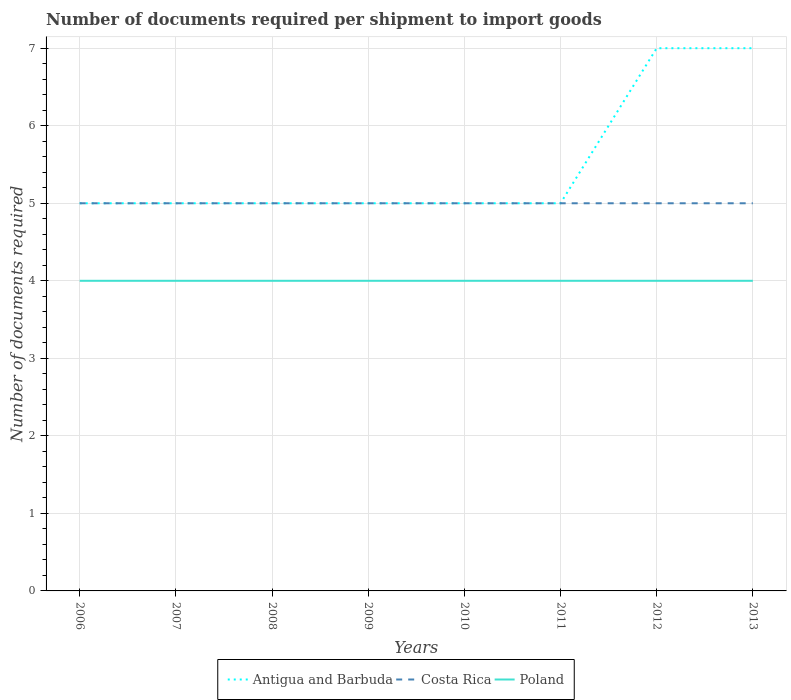How many different coloured lines are there?
Make the answer very short. 3. Across all years, what is the maximum number of documents required per shipment to import goods in Poland?
Offer a very short reply. 4. In which year was the number of documents required per shipment to import goods in Poland maximum?
Offer a terse response. 2006. What is the total number of documents required per shipment to import goods in Antigua and Barbuda in the graph?
Make the answer very short. -2. What is the difference between the highest and the second highest number of documents required per shipment to import goods in Poland?
Make the answer very short. 0. Is the number of documents required per shipment to import goods in Poland strictly greater than the number of documents required per shipment to import goods in Antigua and Barbuda over the years?
Offer a very short reply. Yes. How many lines are there?
Provide a succinct answer. 3. Where does the legend appear in the graph?
Your answer should be very brief. Bottom center. What is the title of the graph?
Make the answer very short. Number of documents required per shipment to import goods. Does "Singapore" appear as one of the legend labels in the graph?
Ensure brevity in your answer.  No. What is the label or title of the Y-axis?
Offer a very short reply. Number of documents required. What is the Number of documents required in Costa Rica in 2006?
Your response must be concise. 5. What is the Number of documents required of Poland in 2006?
Your answer should be compact. 4. What is the Number of documents required in Poland in 2007?
Your answer should be very brief. 4. What is the Number of documents required of Antigua and Barbuda in 2008?
Your answer should be compact. 5. What is the Number of documents required of Costa Rica in 2008?
Provide a succinct answer. 5. What is the Number of documents required in Poland in 2008?
Provide a short and direct response. 4. What is the Number of documents required of Costa Rica in 2009?
Make the answer very short. 5. What is the Number of documents required in Poland in 2009?
Offer a very short reply. 4. What is the Number of documents required of Costa Rica in 2011?
Offer a terse response. 5. What is the Number of documents required in Poland in 2011?
Give a very brief answer. 4. What is the Number of documents required of Antigua and Barbuda in 2012?
Your response must be concise. 7. What is the Number of documents required of Poland in 2012?
Make the answer very short. 4. What is the Number of documents required in Antigua and Barbuda in 2013?
Ensure brevity in your answer.  7. What is the Number of documents required of Costa Rica in 2013?
Your response must be concise. 5. What is the Number of documents required in Poland in 2013?
Your answer should be very brief. 4. Across all years, what is the maximum Number of documents required of Antigua and Barbuda?
Give a very brief answer. 7. Across all years, what is the minimum Number of documents required in Costa Rica?
Ensure brevity in your answer.  5. What is the total Number of documents required of Antigua and Barbuda in the graph?
Provide a succinct answer. 44. What is the total Number of documents required in Poland in the graph?
Your response must be concise. 32. What is the difference between the Number of documents required of Antigua and Barbuda in 2006 and that in 2007?
Your response must be concise. 0. What is the difference between the Number of documents required of Antigua and Barbuda in 2006 and that in 2008?
Your response must be concise. 0. What is the difference between the Number of documents required of Costa Rica in 2006 and that in 2008?
Offer a terse response. 0. What is the difference between the Number of documents required of Poland in 2006 and that in 2008?
Give a very brief answer. 0. What is the difference between the Number of documents required of Poland in 2006 and that in 2009?
Offer a terse response. 0. What is the difference between the Number of documents required of Costa Rica in 2006 and that in 2011?
Keep it short and to the point. 0. What is the difference between the Number of documents required in Poland in 2006 and that in 2011?
Provide a succinct answer. 0. What is the difference between the Number of documents required of Costa Rica in 2006 and that in 2012?
Your response must be concise. 0. What is the difference between the Number of documents required in Antigua and Barbuda in 2007 and that in 2008?
Make the answer very short. 0. What is the difference between the Number of documents required of Costa Rica in 2007 and that in 2008?
Your answer should be very brief. 0. What is the difference between the Number of documents required in Antigua and Barbuda in 2007 and that in 2009?
Your answer should be compact. 0. What is the difference between the Number of documents required in Costa Rica in 2007 and that in 2009?
Your response must be concise. 0. What is the difference between the Number of documents required in Antigua and Barbuda in 2007 and that in 2010?
Keep it short and to the point. 0. What is the difference between the Number of documents required in Costa Rica in 2007 and that in 2010?
Make the answer very short. 0. What is the difference between the Number of documents required in Costa Rica in 2007 and that in 2011?
Your response must be concise. 0. What is the difference between the Number of documents required in Costa Rica in 2007 and that in 2013?
Make the answer very short. 0. What is the difference between the Number of documents required in Antigua and Barbuda in 2008 and that in 2010?
Your answer should be very brief. 0. What is the difference between the Number of documents required of Costa Rica in 2008 and that in 2011?
Make the answer very short. 0. What is the difference between the Number of documents required in Poland in 2008 and that in 2011?
Your response must be concise. 0. What is the difference between the Number of documents required of Antigua and Barbuda in 2008 and that in 2012?
Ensure brevity in your answer.  -2. What is the difference between the Number of documents required in Poland in 2008 and that in 2012?
Provide a succinct answer. 0. What is the difference between the Number of documents required in Poland in 2008 and that in 2013?
Offer a very short reply. 0. What is the difference between the Number of documents required in Costa Rica in 2009 and that in 2010?
Ensure brevity in your answer.  0. What is the difference between the Number of documents required of Poland in 2009 and that in 2010?
Give a very brief answer. 0. What is the difference between the Number of documents required in Costa Rica in 2009 and that in 2011?
Your answer should be very brief. 0. What is the difference between the Number of documents required in Antigua and Barbuda in 2009 and that in 2012?
Offer a very short reply. -2. What is the difference between the Number of documents required of Poland in 2009 and that in 2012?
Give a very brief answer. 0. What is the difference between the Number of documents required of Poland in 2009 and that in 2013?
Make the answer very short. 0. What is the difference between the Number of documents required of Poland in 2010 and that in 2011?
Provide a succinct answer. 0. What is the difference between the Number of documents required of Costa Rica in 2010 and that in 2012?
Provide a succinct answer. 0. What is the difference between the Number of documents required in Costa Rica in 2010 and that in 2013?
Give a very brief answer. 0. What is the difference between the Number of documents required in Poland in 2010 and that in 2013?
Give a very brief answer. 0. What is the difference between the Number of documents required of Costa Rica in 2011 and that in 2012?
Provide a short and direct response. 0. What is the difference between the Number of documents required in Poland in 2011 and that in 2012?
Provide a short and direct response. 0. What is the difference between the Number of documents required in Costa Rica in 2011 and that in 2013?
Your answer should be compact. 0. What is the difference between the Number of documents required of Antigua and Barbuda in 2012 and that in 2013?
Make the answer very short. 0. What is the difference between the Number of documents required of Antigua and Barbuda in 2006 and the Number of documents required of Costa Rica in 2007?
Make the answer very short. 0. What is the difference between the Number of documents required in Antigua and Barbuda in 2006 and the Number of documents required in Costa Rica in 2009?
Make the answer very short. 0. What is the difference between the Number of documents required in Costa Rica in 2006 and the Number of documents required in Poland in 2009?
Offer a terse response. 1. What is the difference between the Number of documents required in Antigua and Barbuda in 2006 and the Number of documents required in Poland in 2010?
Offer a very short reply. 1. What is the difference between the Number of documents required in Costa Rica in 2006 and the Number of documents required in Poland in 2010?
Keep it short and to the point. 1. What is the difference between the Number of documents required in Antigua and Barbuda in 2006 and the Number of documents required in Costa Rica in 2011?
Your answer should be compact. 0. What is the difference between the Number of documents required of Antigua and Barbuda in 2006 and the Number of documents required of Poland in 2012?
Your answer should be compact. 1. What is the difference between the Number of documents required in Costa Rica in 2006 and the Number of documents required in Poland in 2013?
Make the answer very short. 1. What is the difference between the Number of documents required in Costa Rica in 2007 and the Number of documents required in Poland in 2008?
Make the answer very short. 1. What is the difference between the Number of documents required of Antigua and Barbuda in 2007 and the Number of documents required of Costa Rica in 2009?
Ensure brevity in your answer.  0. What is the difference between the Number of documents required of Antigua and Barbuda in 2007 and the Number of documents required of Poland in 2009?
Provide a succinct answer. 1. What is the difference between the Number of documents required of Costa Rica in 2007 and the Number of documents required of Poland in 2009?
Provide a succinct answer. 1. What is the difference between the Number of documents required in Antigua and Barbuda in 2007 and the Number of documents required in Costa Rica in 2010?
Provide a short and direct response. 0. What is the difference between the Number of documents required in Antigua and Barbuda in 2007 and the Number of documents required in Poland in 2010?
Your response must be concise. 1. What is the difference between the Number of documents required of Costa Rica in 2007 and the Number of documents required of Poland in 2010?
Provide a succinct answer. 1. What is the difference between the Number of documents required of Antigua and Barbuda in 2007 and the Number of documents required of Poland in 2011?
Give a very brief answer. 1. What is the difference between the Number of documents required of Costa Rica in 2007 and the Number of documents required of Poland in 2011?
Provide a short and direct response. 1. What is the difference between the Number of documents required in Antigua and Barbuda in 2007 and the Number of documents required in Poland in 2012?
Provide a short and direct response. 1. What is the difference between the Number of documents required of Costa Rica in 2007 and the Number of documents required of Poland in 2013?
Keep it short and to the point. 1. What is the difference between the Number of documents required in Antigua and Barbuda in 2008 and the Number of documents required in Costa Rica in 2009?
Ensure brevity in your answer.  0. What is the difference between the Number of documents required in Costa Rica in 2008 and the Number of documents required in Poland in 2010?
Ensure brevity in your answer.  1. What is the difference between the Number of documents required in Antigua and Barbuda in 2008 and the Number of documents required in Costa Rica in 2011?
Provide a succinct answer. 0. What is the difference between the Number of documents required of Antigua and Barbuda in 2008 and the Number of documents required of Poland in 2011?
Make the answer very short. 1. What is the difference between the Number of documents required of Costa Rica in 2008 and the Number of documents required of Poland in 2011?
Offer a terse response. 1. What is the difference between the Number of documents required of Antigua and Barbuda in 2008 and the Number of documents required of Costa Rica in 2012?
Ensure brevity in your answer.  0. What is the difference between the Number of documents required in Costa Rica in 2008 and the Number of documents required in Poland in 2012?
Ensure brevity in your answer.  1. What is the difference between the Number of documents required of Antigua and Barbuda in 2008 and the Number of documents required of Poland in 2013?
Provide a succinct answer. 1. What is the difference between the Number of documents required of Antigua and Barbuda in 2009 and the Number of documents required of Costa Rica in 2010?
Provide a short and direct response. 0. What is the difference between the Number of documents required in Antigua and Barbuda in 2009 and the Number of documents required in Costa Rica in 2011?
Your answer should be very brief. 0. What is the difference between the Number of documents required in Antigua and Barbuda in 2009 and the Number of documents required in Poland in 2011?
Your answer should be very brief. 1. What is the difference between the Number of documents required in Costa Rica in 2009 and the Number of documents required in Poland in 2011?
Your answer should be compact. 1. What is the difference between the Number of documents required in Antigua and Barbuda in 2009 and the Number of documents required in Costa Rica in 2012?
Ensure brevity in your answer.  0. What is the difference between the Number of documents required of Costa Rica in 2009 and the Number of documents required of Poland in 2012?
Offer a terse response. 1. What is the difference between the Number of documents required of Antigua and Barbuda in 2009 and the Number of documents required of Poland in 2013?
Give a very brief answer. 1. What is the difference between the Number of documents required of Antigua and Barbuda in 2010 and the Number of documents required of Costa Rica in 2011?
Give a very brief answer. 0. What is the difference between the Number of documents required of Antigua and Barbuda in 2010 and the Number of documents required of Poland in 2012?
Offer a terse response. 1. What is the difference between the Number of documents required of Costa Rica in 2010 and the Number of documents required of Poland in 2012?
Ensure brevity in your answer.  1. What is the difference between the Number of documents required of Antigua and Barbuda in 2010 and the Number of documents required of Costa Rica in 2013?
Offer a terse response. 0. What is the difference between the Number of documents required of Costa Rica in 2010 and the Number of documents required of Poland in 2013?
Keep it short and to the point. 1. What is the difference between the Number of documents required in Antigua and Barbuda in 2011 and the Number of documents required in Poland in 2012?
Ensure brevity in your answer.  1. What is the difference between the Number of documents required in Antigua and Barbuda in 2011 and the Number of documents required in Costa Rica in 2013?
Keep it short and to the point. 0. What is the difference between the Number of documents required in Antigua and Barbuda in 2011 and the Number of documents required in Poland in 2013?
Keep it short and to the point. 1. What is the difference between the Number of documents required of Antigua and Barbuda in 2012 and the Number of documents required of Poland in 2013?
Offer a terse response. 3. What is the average Number of documents required in Antigua and Barbuda per year?
Offer a very short reply. 5.5. What is the average Number of documents required of Costa Rica per year?
Your response must be concise. 5. In the year 2006, what is the difference between the Number of documents required of Antigua and Barbuda and Number of documents required of Poland?
Offer a very short reply. 1. In the year 2007, what is the difference between the Number of documents required of Antigua and Barbuda and Number of documents required of Costa Rica?
Make the answer very short. 0. In the year 2007, what is the difference between the Number of documents required of Costa Rica and Number of documents required of Poland?
Keep it short and to the point. 1. In the year 2008, what is the difference between the Number of documents required of Antigua and Barbuda and Number of documents required of Costa Rica?
Your answer should be very brief. 0. In the year 2008, what is the difference between the Number of documents required in Costa Rica and Number of documents required in Poland?
Your answer should be very brief. 1. In the year 2009, what is the difference between the Number of documents required of Costa Rica and Number of documents required of Poland?
Your answer should be very brief. 1. In the year 2010, what is the difference between the Number of documents required of Antigua and Barbuda and Number of documents required of Costa Rica?
Your answer should be compact. 0. In the year 2010, what is the difference between the Number of documents required in Antigua and Barbuda and Number of documents required in Poland?
Offer a very short reply. 1. In the year 2011, what is the difference between the Number of documents required of Antigua and Barbuda and Number of documents required of Poland?
Your response must be concise. 1. In the year 2011, what is the difference between the Number of documents required in Costa Rica and Number of documents required in Poland?
Make the answer very short. 1. In the year 2012, what is the difference between the Number of documents required in Antigua and Barbuda and Number of documents required in Poland?
Offer a terse response. 3. In the year 2013, what is the difference between the Number of documents required of Antigua and Barbuda and Number of documents required of Poland?
Your response must be concise. 3. In the year 2013, what is the difference between the Number of documents required of Costa Rica and Number of documents required of Poland?
Provide a succinct answer. 1. What is the ratio of the Number of documents required of Antigua and Barbuda in 2006 to that in 2007?
Keep it short and to the point. 1. What is the ratio of the Number of documents required of Costa Rica in 2006 to that in 2007?
Your response must be concise. 1. What is the ratio of the Number of documents required of Antigua and Barbuda in 2006 to that in 2008?
Your answer should be very brief. 1. What is the ratio of the Number of documents required of Poland in 2006 to that in 2008?
Your answer should be very brief. 1. What is the ratio of the Number of documents required in Costa Rica in 2006 to that in 2009?
Offer a very short reply. 1. What is the ratio of the Number of documents required of Poland in 2006 to that in 2009?
Provide a succinct answer. 1. What is the ratio of the Number of documents required of Antigua and Barbuda in 2006 to that in 2010?
Make the answer very short. 1. What is the ratio of the Number of documents required in Antigua and Barbuda in 2006 to that in 2011?
Your answer should be very brief. 1. What is the ratio of the Number of documents required of Costa Rica in 2006 to that in 2011?
Make the answer very short. 1. What is the ratio of the Number of documents required of Antigua and Barbuda in 2006 to that in 2012?
Make the answer very short. 0.71. What is the ratio of the Number of documents required of Costa Rica in 2006 to that in 2013?
Give a very brief answer. 1. What is the ratio of the Number of documents required in Poland in 2006 to that in 2013?
Ensure brevity in your answer.  1. What is the ratio of the Number of documents required of Costa Rica in 2007 to that in 2008?
Make the answer very short. 1. What is the ratio of the Number of documents required of Poland in 2007 to that in 2008?
Provide a short and direct response. 1. What is the ratio of the Number of documents required in Antigua and Barbuda in 2007 to that in 2009?
Make the answer very short. 1. What is the ratio of the Number of documents required in Poland in 2007 to that in 2009?
Make the answer very short. 1. What is the ratio of the Number of documents required of Costa Rica in 2007 to that in 2010?
Offer a terse response. 1. What is the ratio of the Number of documents required of Poland in 2007 to that in 2010?
Your answer should be very brief. 1. What is the ratio of the Number of documents required in Poland in 2007 to that in 2011?
Provide a succinct answer. 1. What is the ratio of the Number of documents required in Antigua and Barbuda in 2007 to that in 2012?
Your answer should be compact. 0.71. What is the ratio of the Number of documents required of Poland in 2007 to that in 2012?
Your response must be concise. 1. What is the ratio of the Number of documents required in Antigua and Barbuda in 2007 to that in 2013?
Your answer should be compact. 0.71. What is the ratio of the Number of documents required in Poland in 2007 to that in 2013?
Offer a very short reply. 1. What is the ratio of the Number of documents required of Costa Rica in 2008 to that in 2009?
Give a very brief answer. 1. What is the ratio of the Number of documents required of Poland in 2008 to that in 2009?
Your response must be concise. 1. What is the ratio of the Number of documents required of Antigua and Barbuda in 2008 to that in 2010?
Your response must be concise. 1. What is the ratio of the Number of documents required of Costa Rica in 2008 to that in 2010?
Your answer should be very brief. 1. What is the ratio of the Number of documents required in Costa Rica in 2008 to that in 2011?
Provide a short and direct response. 1. What is the ratio of the Number of documents required of Antigua and Barbuda in 2008 to that in 2012?
Ensure brevity in your answer.  0.71. What is the ratio of the Number of documents required in Poland in 2008 to that in 2012?
Make the answer very short. 1. What is the ratio of the Number of documents required in Antigua and Barbuda in 2008 to that in 2013?
Provide a short and direct response. 0.71. What is the ratio of the Number of documents required of Costa Rica in 2008 to that in 2013?
Give a very brief answer. 1. What is the ratio of the Number of documents required in Costa Rica in 2009 to that in 2010?
Keep it short and to the point. 1. What is the ratio of the Number of documents required of Poland in 2009 to that in 2010?
Provide a short and direct response. 1. What is the ratio of the Number of documents required of Antigua and Barbuda in 2009 to that in 2011?
Offer a very short reply. 1. What is the ratio of the Number of documents required in Costa Rica in 2009 to that in 2011?
Give a very brief answer. 1. What is the ratio of the Number of documents required of Costa Rica in 2009 to that in 2013?
Make the answer very short. 1. What is the ratio of the Number of documents required in Poland in 2010 to that in 2013?
Offer a terse response. 1. What is the ratio of the Number of documents required in Antigua and Barbuda in 2011 to that in 2012?
Give a very brief answer. 0.71. What is the ratio of the Number of documents required in Antigua and Barbuda in 2011 to that in 2013?
Your answer should be compact. 0.71. What is the ratio of the Number of documents required of Antigua and Barbuda in 2012 to that in 2013?
Make the answer very short. 1. What is the ratio of the Number of documents required of Costa Rica in 2012 to that in 2013?
Your answer should be compact. 1. What is the difference between the highest and the second highest Number of documents required in Antigua and Barbuda?
Offer a very short reply. 0. What is the difference between the highest and the second highest Number of documents required in Poland?
Your answer should be very brief. 0. What is the difference between the highest and the lowest Number of documents required of Antigua and Barbuda?
Offer a terse response. 2. What is the difference between the highest and the lowest Number of documents required in Costa Rica?
Provide a short and direct response. 0. What is the difference between the highest and the lowest Number of documents required of Poland?
Offer a very short reply. 0. 